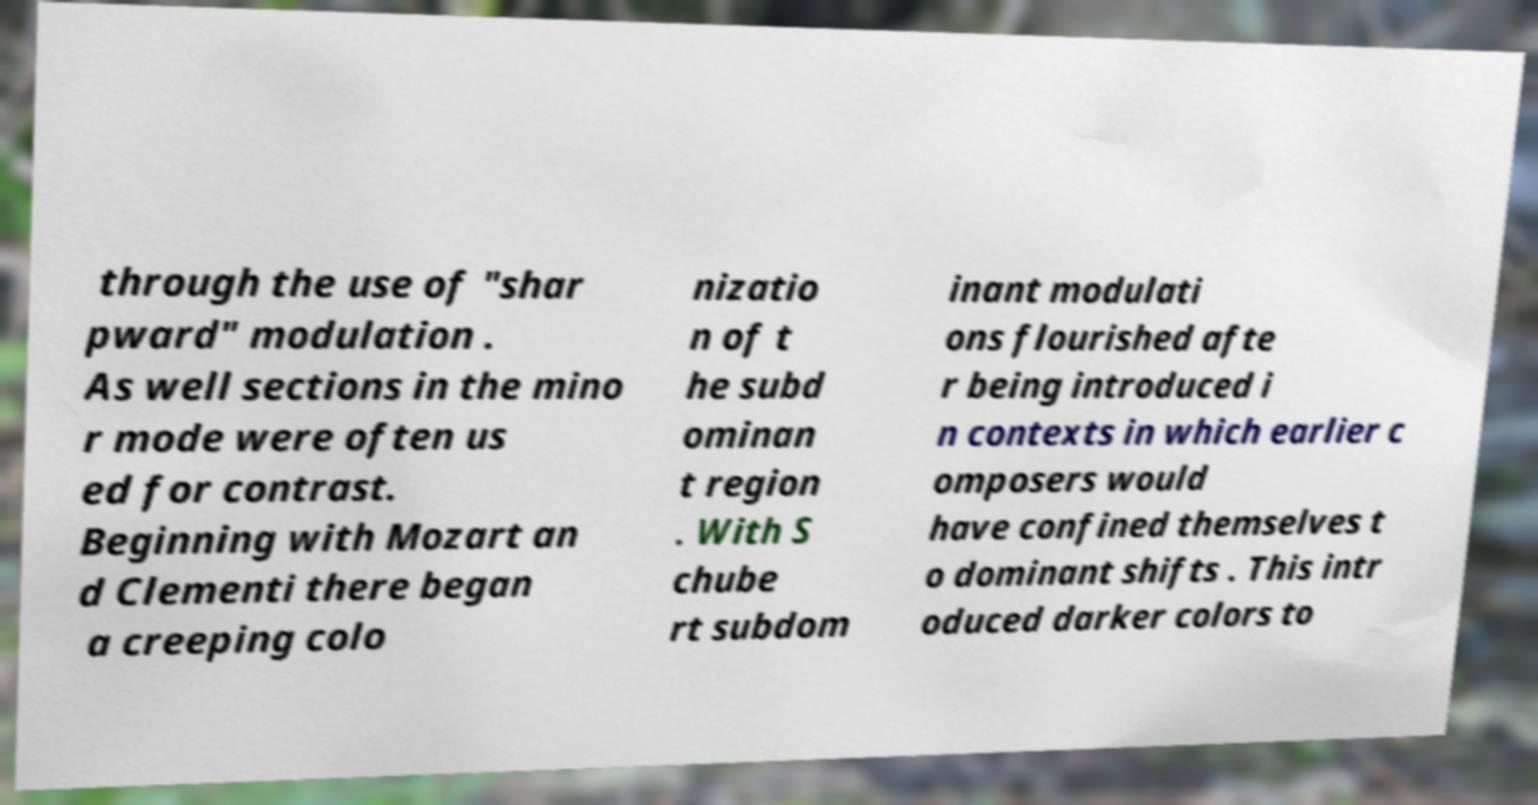Could you extract and type out the text from this image? through the use of "shar pward" modulation . As well sections in the mino r mode were often us ed for contrast. Beginning with Mozart an d Clementi there began a creeping colo nizatio n of t he subd ominan t region . With S chube rt subdom inant modulati ons flourished afte r being introduced i n contexts in which earlier c omposers would have confined themselves t o dominant shifts . This intr oduced darker colors to 